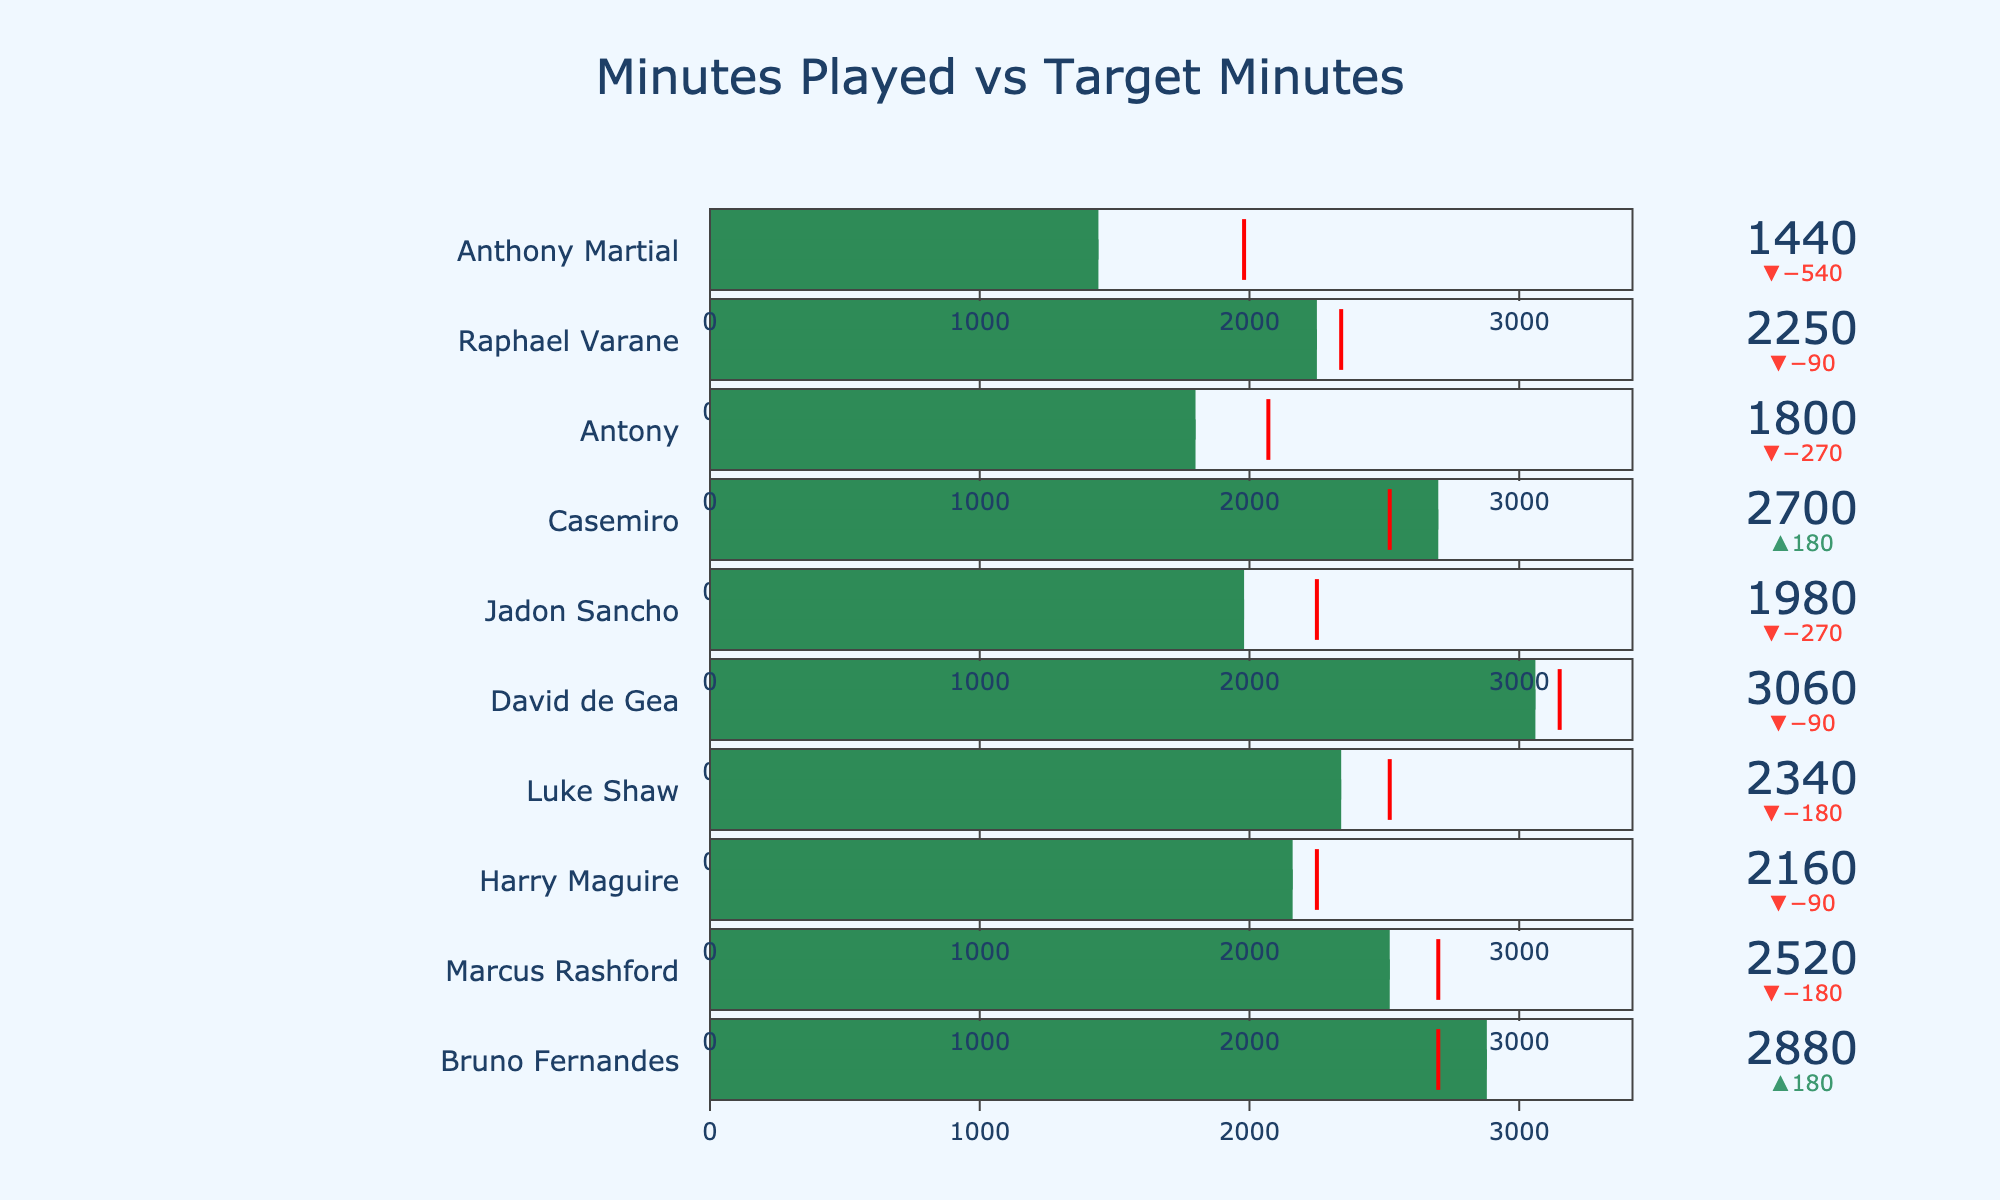How many players have minutes played exceeding their target minutes? Identify the players and compare their actual and target minutes to count how many players exceed their targets.
Answer: 4 players Which player has the highest actual minutes and how much above the target is he? Find the player with the highest actual minutes and calculate the difference between his actual and target minutes.
Answer: David de Gea, 90 minutes What's the total difference between actual and target minutes for the entire squad? For each player, calculate the difference between actual and target minutes; sum all differences (2880-2700) + (2520-2700) + (2160-2250) + (2340-2520) + (3060-3150) + (1980-2250) + (2700-2520) + (1800-2070) + (2250-2340) + (1440-1980). The result is 180 + (-180) + (-90) + (-180) + (-90) + (-270) + 180 + (-270) + (-90) + (-540) = -1350 total minutes.
Answer: -1350 minutes Which players did not meet their target minutes? Identify players for whom the actual minutes are less than the target minutes.
Answer: Marcus Rashford, Harry Maguire, Luke Shaw, Jadon Sancho, Antony, Raphael Varane, Anthony Martial Which player has the smallest gap between actual and target minutes, and what is the gap? For each player, calculate the absolute difference between actual and target minutes and find the smallest gap.
Answer: Harry Maguire, 90 minutes What is the color indicating the target minutes in the figure? Observe the visual element used for target minutes and describe its color.
Answer: Red Who played the closest to their maximum minutes and how close were they? Identify the player with actual minutes closest to their maximum minutes and compute the difference.
Answer: David de Gea, 360 minutes below Which player had the most significant shortfall compared to their target minutes, and what is the shortfall? Calculate the gap between actual and target minutes for each player and identify the largest shortfall.
Answer: Anthony Martial, 540 minutes How many players have actual minutes within 100 minutes of their target minutes? Calculate the difference between actual and target minutes for each player and count those within 100 minutes.
Answer: 2 players (Bruno Fernandes, Harry Maguire) What is the average difference between actual and target minutes for the squad? For each player, calculate the difference between actual and target minutes, then find the average: (-1350 total difference) / 10 players = -135.
Answer: -135 minutes 